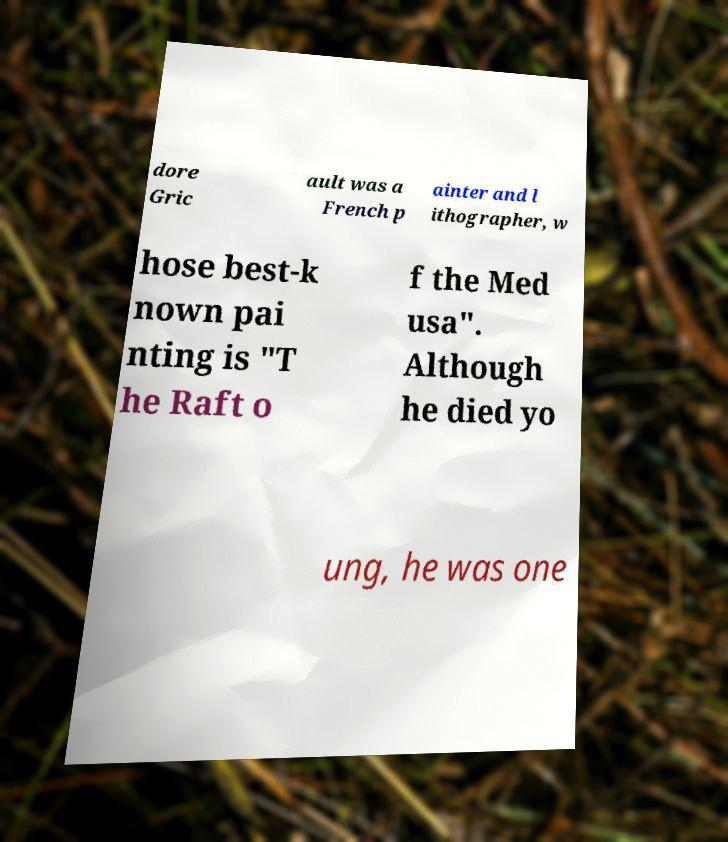What messages or text are displayed in this image? I need them in a readable, typed format. dore Gric ault was a French p ainter and l ithographer, w hose best-k nown pai nting is "T he Raft o f the Med usa". Although he died yo ung, he was one 